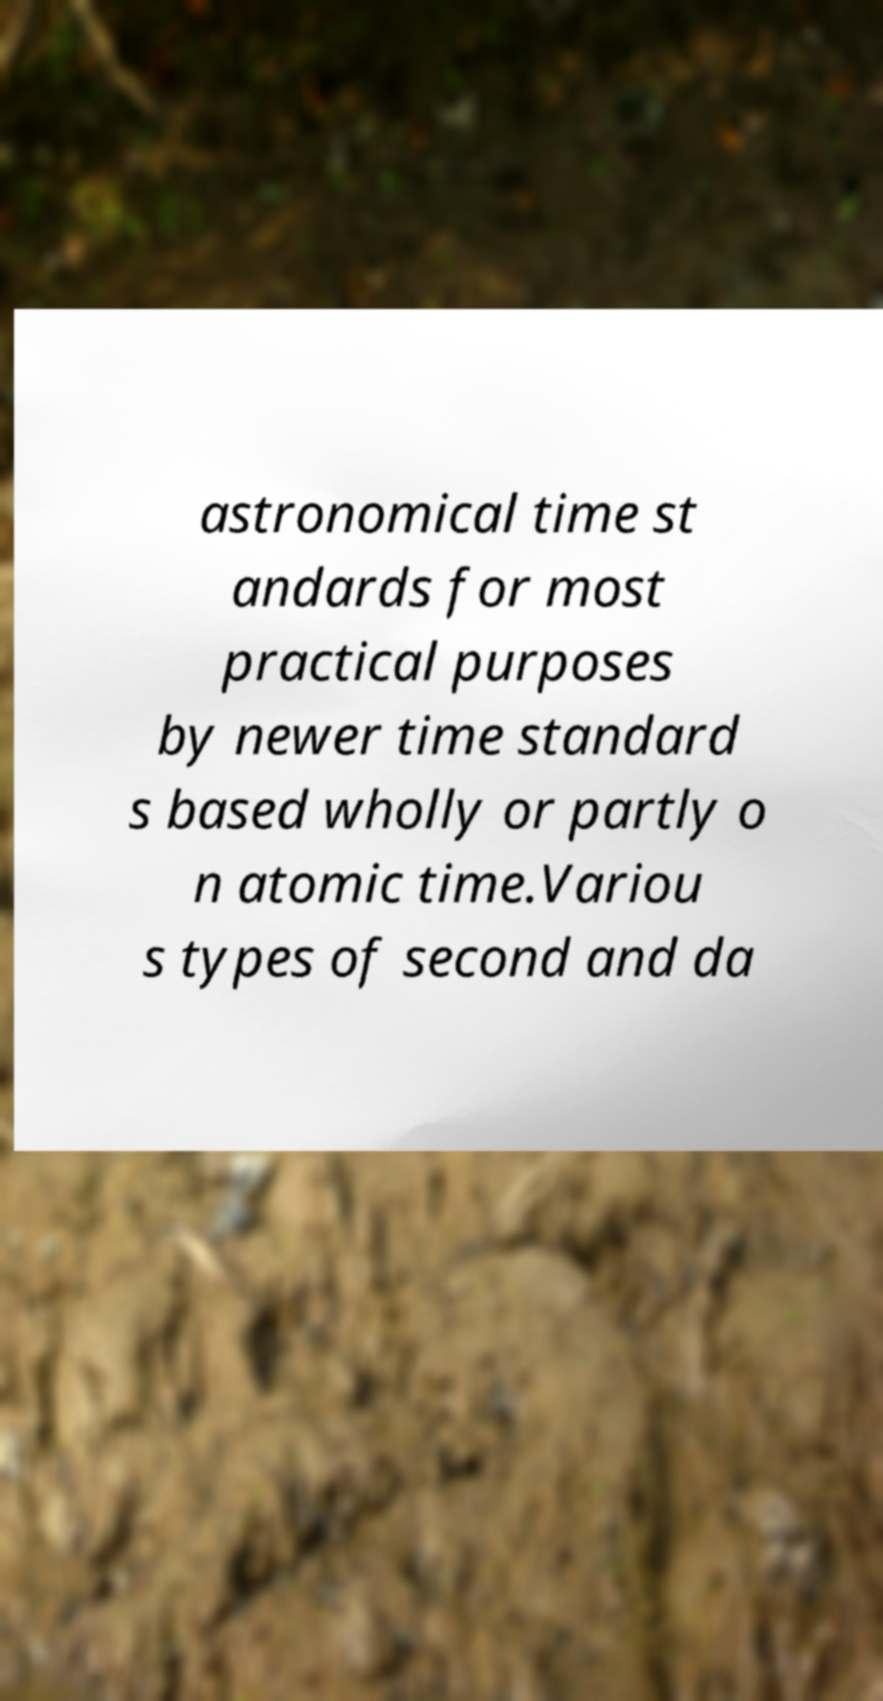Can you read and provide the text displayed in the image?This photo seems to have some interesting text. Can you extract and type it out for me? astronomical time st andards for most practical purposes by newer time standard s based wholly or partly o n atomic time.Variou s types of second and da 